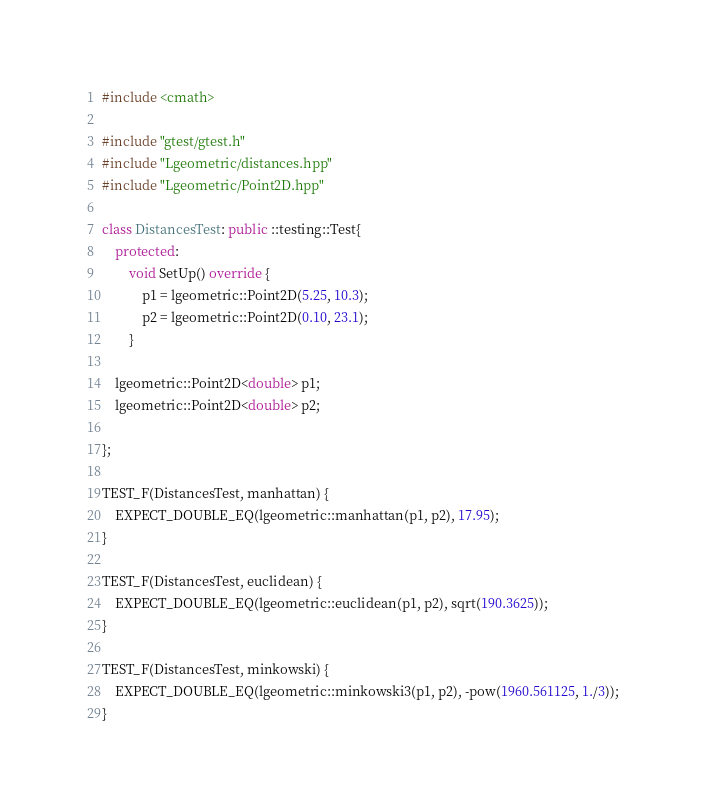<code> <loc_0><loc_0><loc_500><loc_500><_C++_>#include <cmath>

#include "gtest/gtest.h"
#include "Lgeometric/distances.hpp"
#include "Lgeometric/Point2D.hpp"

class DistancesTest: public ::testing::Test{
    protected:
        void SetUp() override {
            p1 = lgeometric::Point2D(5.25, 10.3); 
            p2 = lgeometric::Point2D(0.10, 23.1); 
        }

    lgeometric::Point2D<double> p1;
    lgeometric::Point2D<double> p2;
    
};

TEST_F(DistancesTest, manhattan) {
    EXPECT_DOUBLE_EQ(lgeometric::manhattan(p1, p2), 17.95);
}

TEST_F(DistancesTest, euclidean) {
    EXPECT_DOUBLE_EQ(lgeometric::euclidean(p1, p2), sqrt(190.3625));   
}

TEST_F(DistancesTest, minkowski) {
    EXPECT_DOUBLE_EQ(lgeometric::minkowski3(p1, p2), -pow(1960.561125, 1./3));
}
</code> 